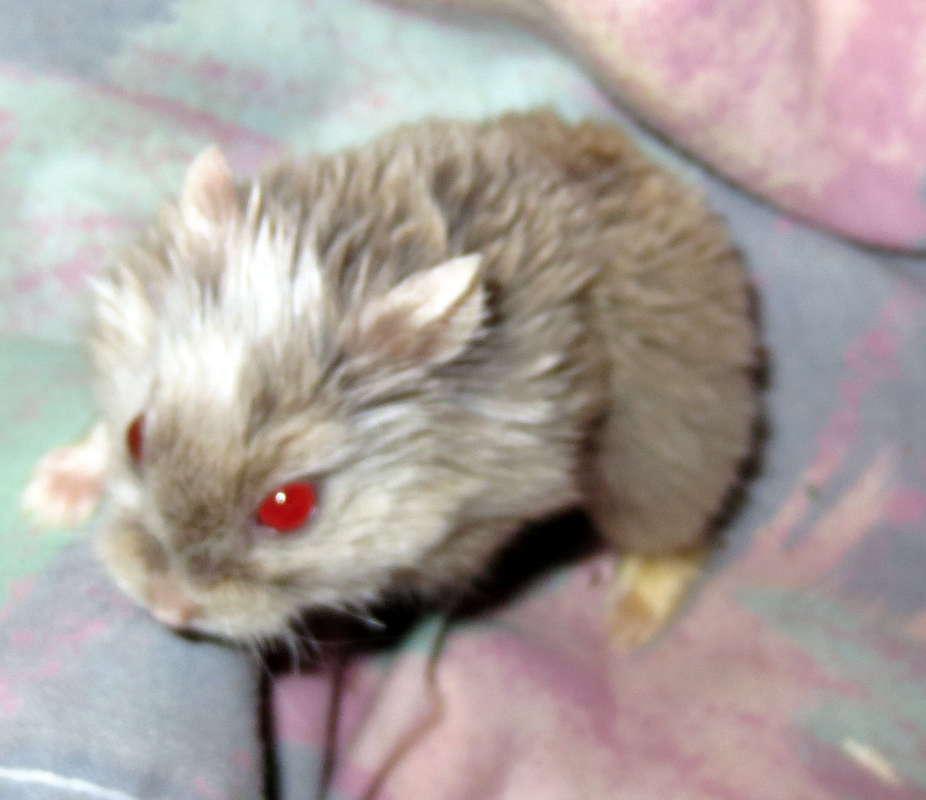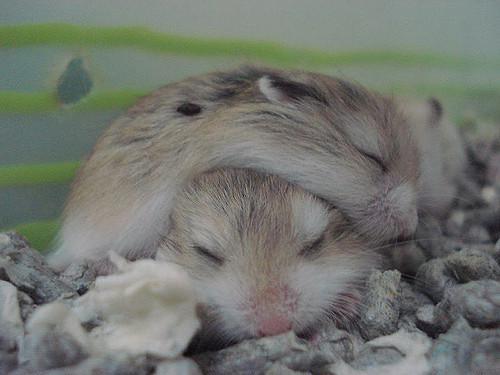The first image is the image on the left, the second image is the image on the right. Considering the images on both sides, is "The right image contains at least two rodents." valid? Answer yes or no. Yes. The first image is the image on the left, the second image is the image on the right. Assess this claim about the two images: "There are exactly 3 hamsters.". Correct or not? Answer yes or no. Yes. 